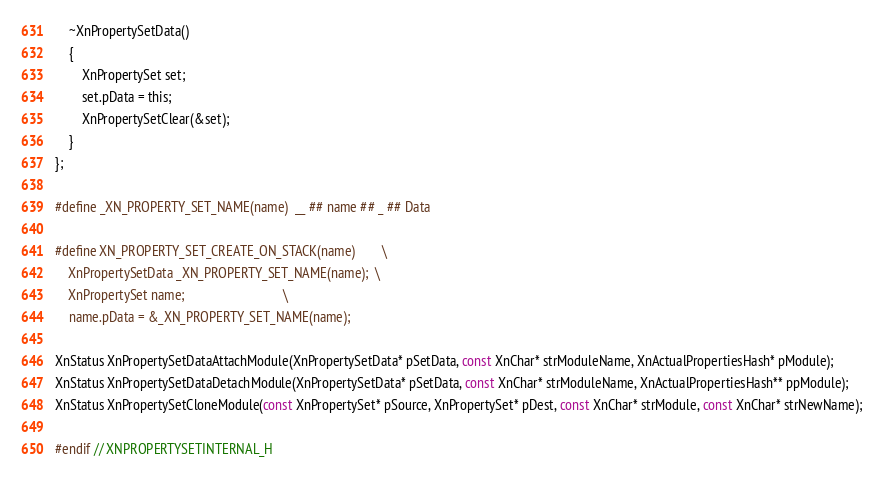Convert code to text. <code><loc_0><loc_0><loc_500><loc_500><_C_>	~XnPropertySetData()
	{
		XnPropertySet set;
		set.pData = this;
		XnPropertySetClear(&set);
	}
};

#define _XN_PROPERTY_SET_NAME(name)	__ ## name ## _ ## Data

#define XN_PROPERTY_SET_CREATE_ON_STACK(name)		\
	XnPropertySetData _XN_PROPERTY_SET_NAME(name);	\
	XnPropertySet name;								\
	name.pData = &_XN_PROPERTY_SET_NAME(name);

XnStatus XnPropertySetDataAttachModule(XnPropertySetData* pSetData, const XnChar* strModuleName, XnActualPropertiesHash* pModule);
XnStatus XnPropertySetDataDetachModule(XnPropertySetData* pSetData, const XnChar* strModuleName, XnActualPropertiesHash** ppModule);
XnStatus XnPropertySetCloneModule(const XnPropertySet* pSource, XnPropertySet* pDest, const XnChar* strModule, const XnChar* strNewName);

#endif // XNPROPERTYSETINTERNAL_H
</code> 